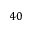<formula> <loc_0><loc_0><loc_500><loc_500>4 0</formula> 